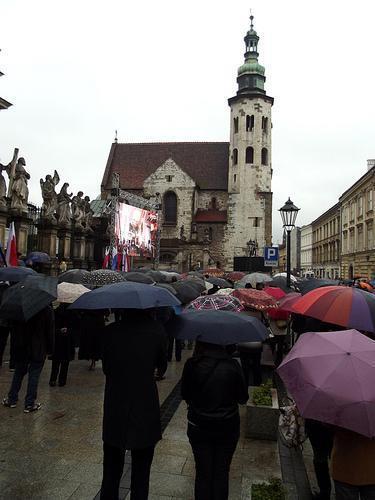How many screens are in the picture?
Give a very brief answer. 1. 